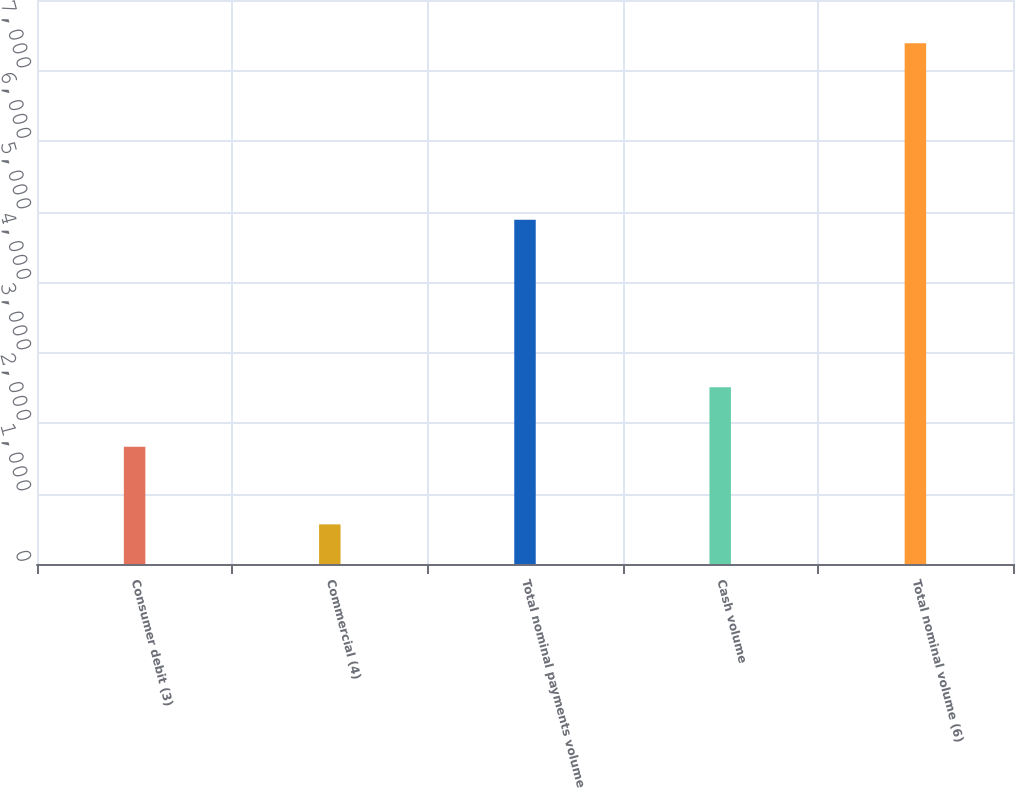<chart> <loc_0><loc_0><loc_500><loc_500><bar_chart><fcel>Consumer debit (3)<fcel>Commercial (4)<fcel>Total nominal payments volume<fcel>Cash volume<fcel>Total nominal volume (6)<nl><fcel>1663<fcel>562<fcel>4882<fcel>2506<fcel>7388<nl></chart> 